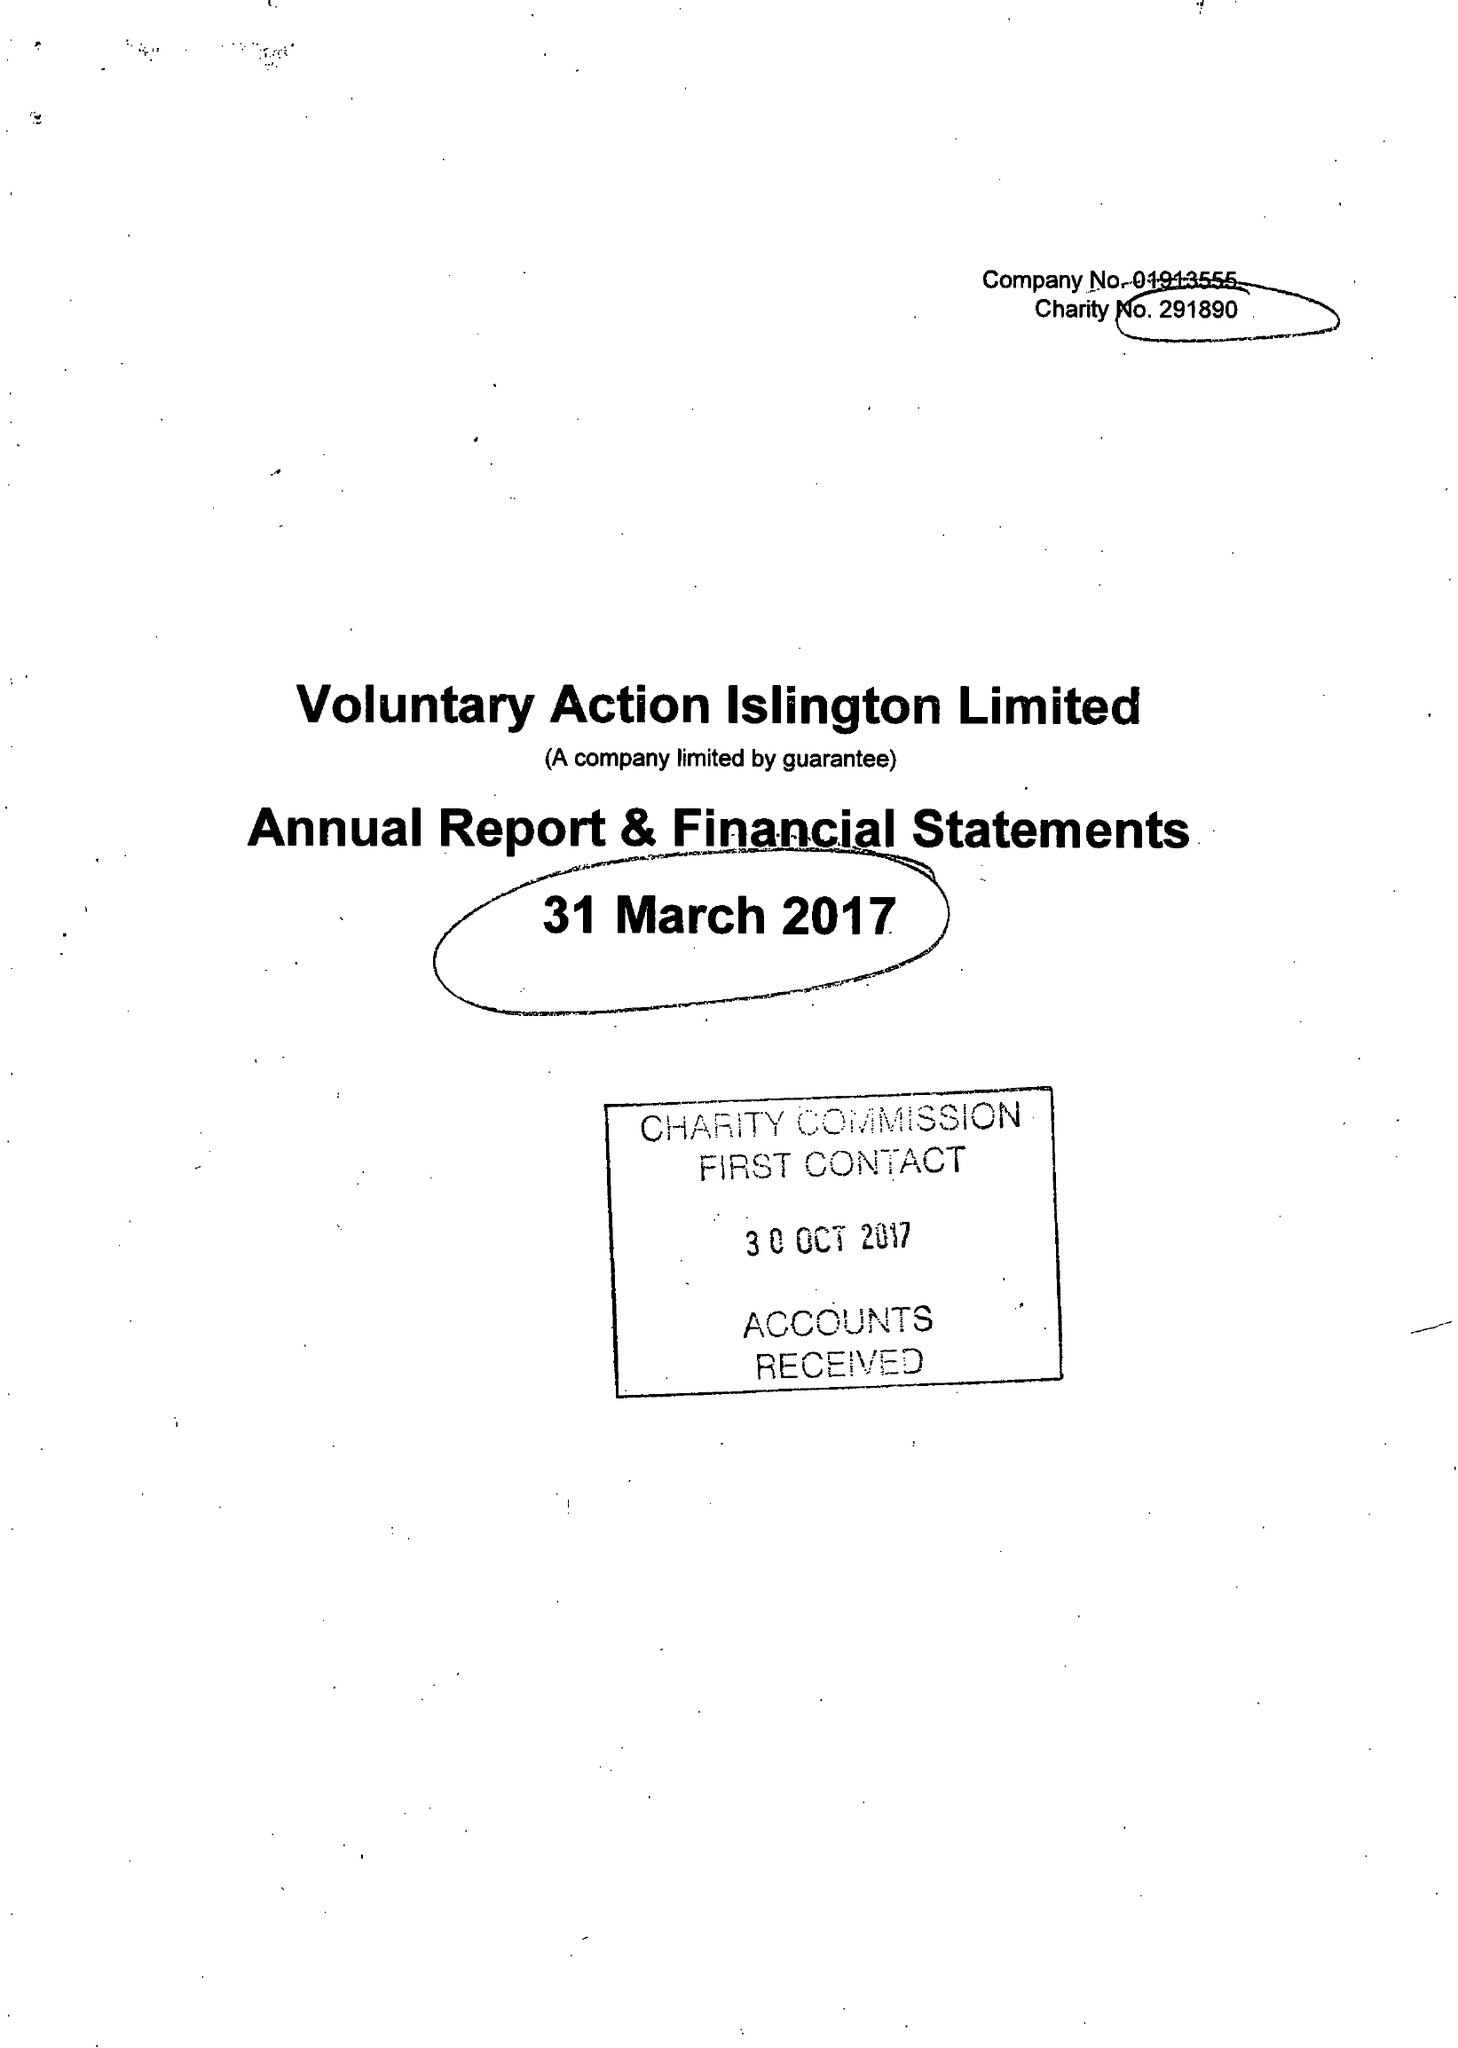What is the value for the report_date?
Answer the question using a single word or phrase. 2017-03-31 